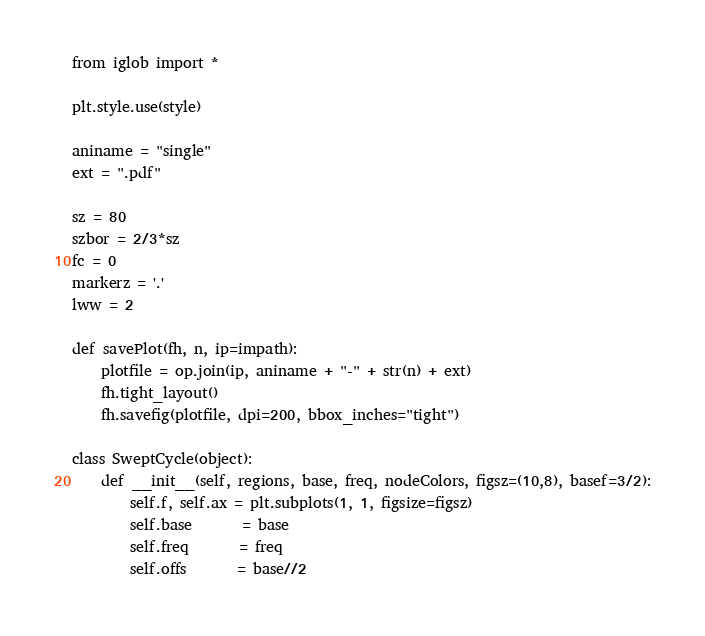<code> <loc_0><loc_0><loc_500><loc_500><_Python_>
from iglob import *

plt.style.use(style)

aniname = "single"
ext = ".pdf"

sz = 80
szbor = 2/3*sz
fc = 0
markerz = '.'
lww = 2

def savePlot(fh, n, ip=impath):
    plotfile = op.join(ip, aniname + "-" + str(n) + ext)
    fh.tight_layout()
    fh.savefig(plotfile, dpi=200, bbox_inches="tight")

class SweptCycle(object):
    def __init__(self, regions, base, freq, nodeColors, figsz=(10,8), basef=3/2):
        self.f, self.ax = plt.subplots(1, 1, figsize=figsz)
        self.base       = base
        self.freq       = freq
        self.offs       = base//2 </code> 